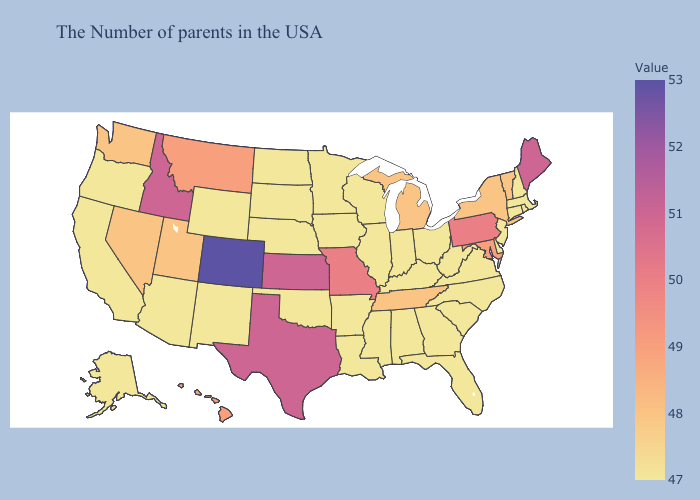Among the states that border Kentucky , which have the highest value?
Quick response, please. Missouri. Which states have the highest value in the USA?
Answer briefly. Colorado. Among the states that border South Dakota , does Montana have the lowest value?
Give a very brief answer. No. Does Colorado have the highest value in the West?
Answer briefly. Yes. 